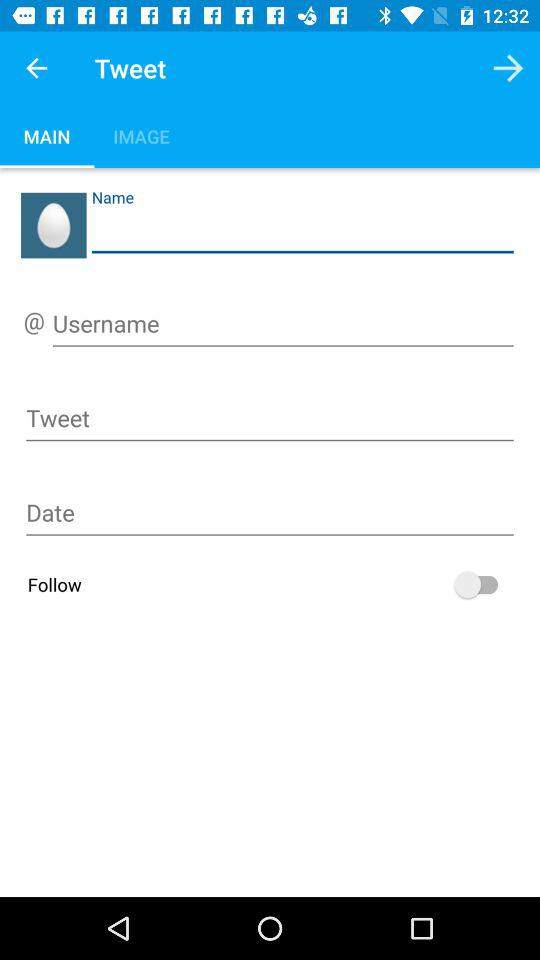Which tab is selected? The selected tab is "MAIN". 